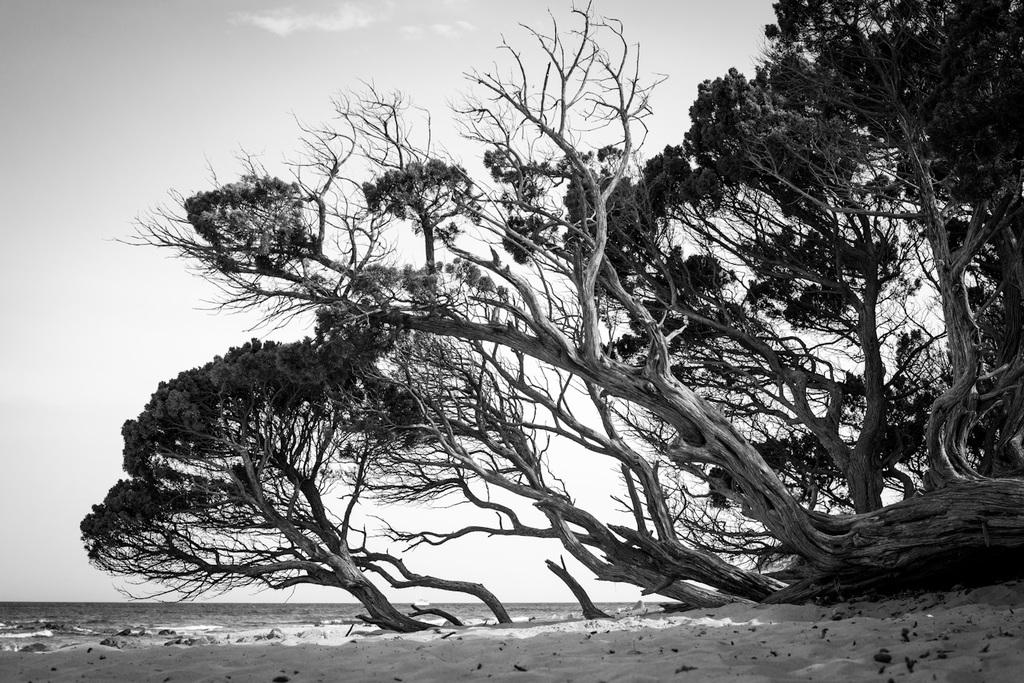What is the primary element visible in the image? There is water in the image. What type of trees can be seen in the image? There are black color trees in the image. What is the trees' base made of? The trees are attached to sand. What is visible at the top of the image? The sky is visible at the top of the image. What is the ladybug writing on the sand in the image? There is no ladybug present in the image, and therefore no writing on the sand can be observed. 